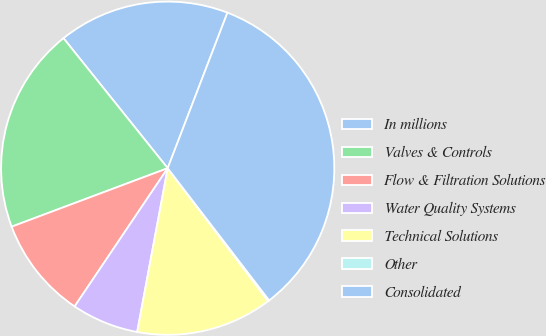Convert chart to OTSL. <chart><loc_0><loc_0><loc_500><loc_500><pie_chart><fcel>In millions<fcel>Valves & Controls<fcel>Flow & Filtration Solutions<fcel>Water Quality Systems<fcel>Technical Solutions<fcel>Other<fcel>Consolidated<nl><fcel>16.59%<fcel>19.95%<fcel>9.86%<fcel>6.5%<fcel>13.23%<fcel>0.12%<fcel>33.74%<nl></chart> 